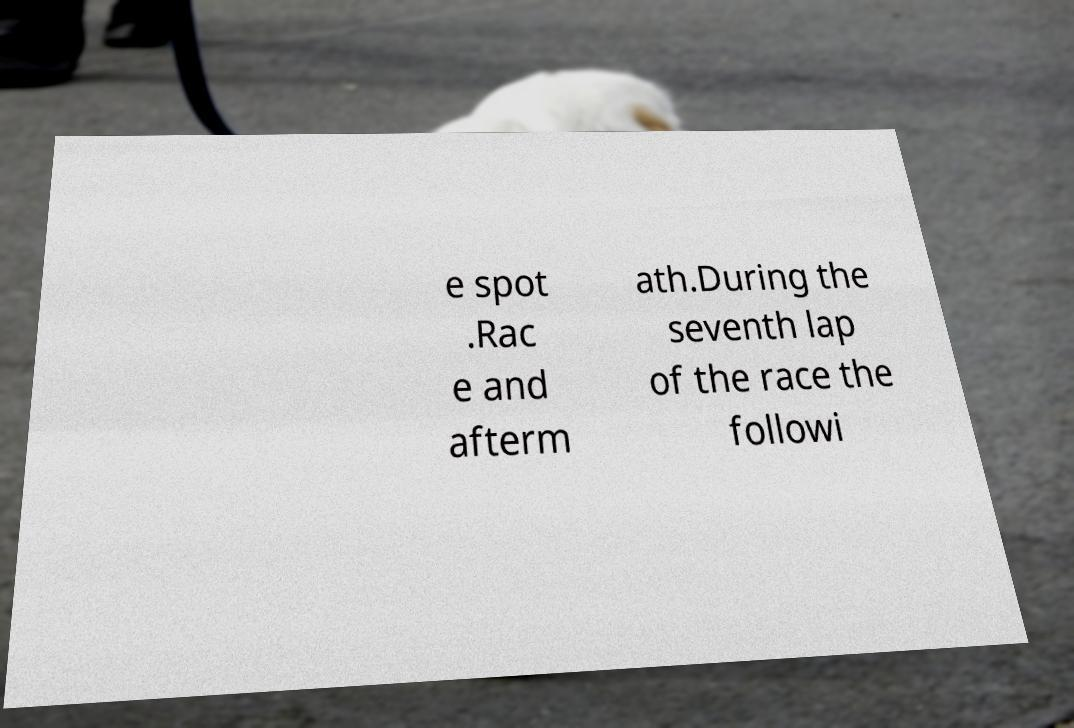Could you extract and type out the text from this image? e spot .Rac e and afterm ath.During the seventh lap of the race the followi 